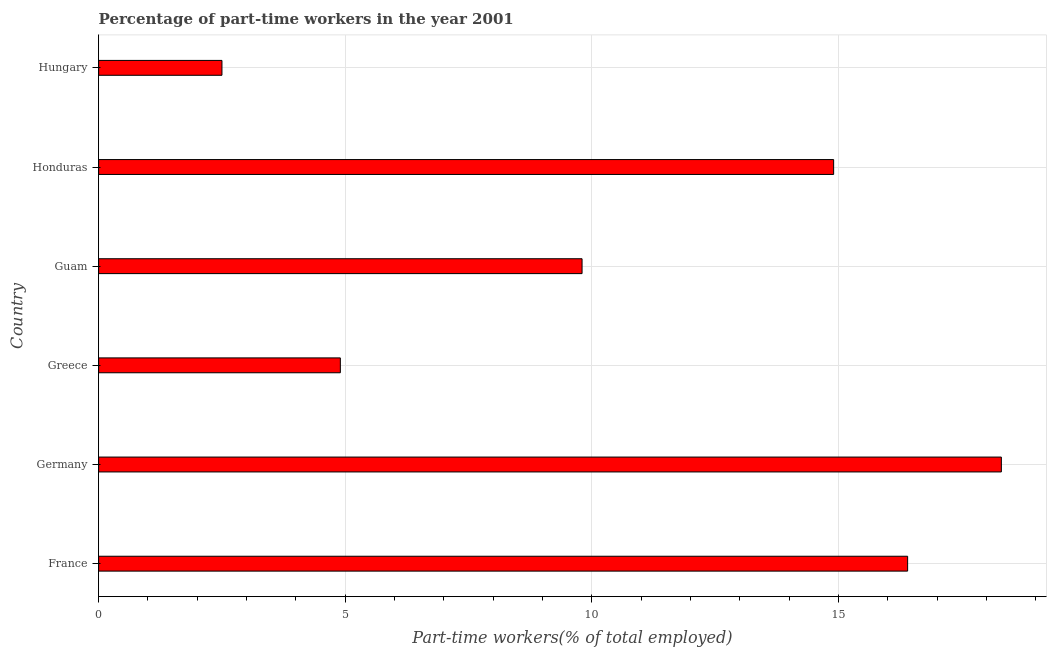Does the graph contain any zero values?
Offer a terse response. No. Does the graph contain grids?
Provide a succinct answer. Yes. What is the title of the graph?
Make the answer very short. Percentage of part-time workers in the year 2001. What is the label or title of the X-axis?
Give a very brief answer. Part-time workers(% of total employed). What is the percentage of part-time workers in Germany?
Give a very brief answer. 18.3. Across all countries, what is the maximum percentage of part-time workers?
Your answer should be compact. 18.3. In which country was the percentage of part-time workers maximum?
Keep it short and to the point. Germany. In which country was the percentage of part-time workers minimum?
Your response must be concise. Hungary. What is the sum of the percentage of part-time workers?
Your answer should be very brief. 66.8. What is the difference between the percentage of part-time workers in Greece and Honduras?
Make the answer very short. -10. What is the average percentage of part-time workers per country?
Give a very brief answer. 11.13. What is the median percentage of part-time workers?
Provide a short and direct response. 12.35. In how many countries, is the percentage of part-time workers greater than 13 %?
Give a very brief answer. 3. What is the ratio of the percentage of part-time workers in Guam to that in Hungary?
Provide a short and direct response. 3.92. Is the sum of the percentage of part-time workers in Greece and Honduras greater than the maximum percentage of part-time workers across all countries?
Make the answer very short. Yes. What is the difference between two consecutive major ticks on the X-axis?
Your response must be concise. 5. Are the values on the major ticks of X-axis written in scientific E-notation?
Ensure brevity in your answer.  No. What is the Part-time workers(% of total employed) of France?
Give a very brief answer. 16.4. What is the Part-time workers(% of total employed) in Germany?
Offer a very short reply. 18.3. What is the Part-time workers(% of total employed) of Greece?
Your response must be concise. 4.9. What is the Part-time workers(% of total employed) in Guam?
Give a very brief answer. 9.8. What is the Part-time workers(% of total employed) in Honduras?
Your answer should be compact. 14.9. What is the Part-time workers(% of total employed) in Hungary?
Keep it short and to the point. 2.5. What is the difference between the Part-time workers(% of total employed) in France and Guam?
Your response must be concise. 6.6. What is the difference between the Part-time workers(% of total employed) in France and Honduras?
Ensure brevity in your answer.  1.5. What is the difference between the Part-time workers(% of total employed) in Germany and Greece?
Your answer should be compact. 13.4. What is the difference between the Part-time workers(% of total employed) in Germany and Honduras?
Your response must be concise. 3.4. What is the difference between the Part-time workers(% of total employed) in Germany and Hungary?
Offer a terse response. 15.8. What is the difference between the Part-time workers(% of total employed) in Greece and Guam?
Your response must be concise. -4.9. What is the difference between the Part-time workers(% of total employed) in Greece and Honduras?
Make the answer very short. -10. What is the difference between the Part-time workers(% of total employed) in Guam and Hungary?
Give a very brief answer. 7.3. What is the difference between the Part-time workers(% of total employed) in Honduras and Hungary?
Ensure brevity in your answer.  12.4. What is the ratio of the Part-time workers(% of total employed) in France to that in Germany?
Offer a very short reply. 0.9. What is the ratio of the Part-time workers(% of total employed) in France to that in Greece?
Offer a very short reply. 3.35. What is the ratio of the Part-time workers(% of total employed) in France to that in Guam?
Offer a terse response. 1.67. What is the ratio of the Part-time workers(% of total employed) in France to that in Honduras?
Ensure brevity in your answer.  1.1. What is the ratio of the Part-time workers(% of total employed) in France to that in Hungary?
Give a very brief answer. 6.56. What is the ratio of the Part-time workers(% of total employed) in Germany to that in Greece?
Provide a short and direct response. 3.73. What is the ratio of the Part-time workers(% of total employed) in Germany to that in Guam?
Offer a terse response. 1.87. What is the ratio of the Part-time workers(% of total employed) in Germany to that in Honduras?
Give a very brief answer. 1.23. What is the ratio of the Part-time workers(% of total employed) in Germany to that in Hungary?
Your answer should be very brief. 7.32. What is the ratio of the Part-time workers(% of total employed) in Greece to that in Honduras?
Offer a very short reply. 0.33. What is the ratio of the Part-time workers(% of total employed) in Greece to that in Hungary?
Give a very brief answer. 1.96. What is the ratio of the Part-time workers(% of total employed) in Guam to that in Honduras?
Give a very brief answer. 0.66. What is the ratio of the Part-time workers(% of total employed) in Guam to that in Hungary?
Your response must be concise. 3.92. What is the ratio of the Part-time workers(% of total employed) in Honduras to that in Hungary?
Provide a succinct answer. 5.96. 